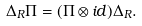Convert formula to latex. <formula><loc_0><loc_0><loc_500><loc_500>\Delta _ { R } \Pi = ( \Pi \otimes i d ) \Delta _ { R } .</formula> 